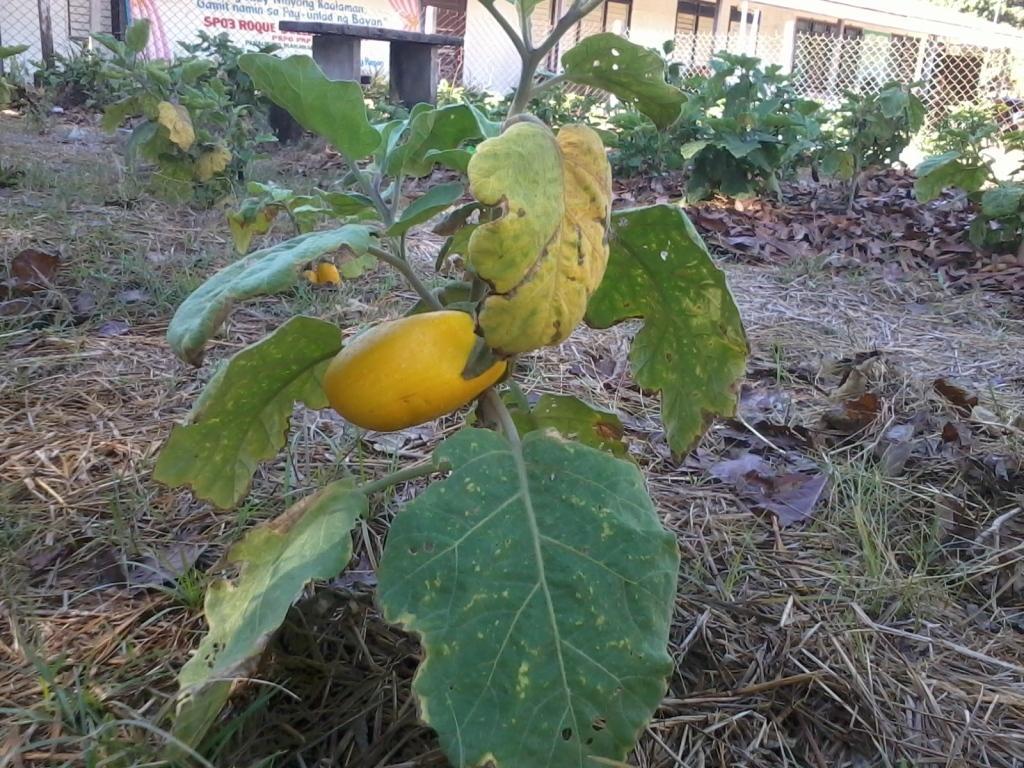Describe this image in one or two sentences. In this picture i can see yellow fruit on the plant. At the bottom i can see many leaves. In the bottom right corner i can see grass. At the top i can see the building. In the top right corner i can see trees, windows and plants. In the top left corner there is a fencing, beside that there is a banner. 